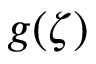<formula> <loc_0><loc_0><loc_500><loc_500>g ( \zeta )</formula> 